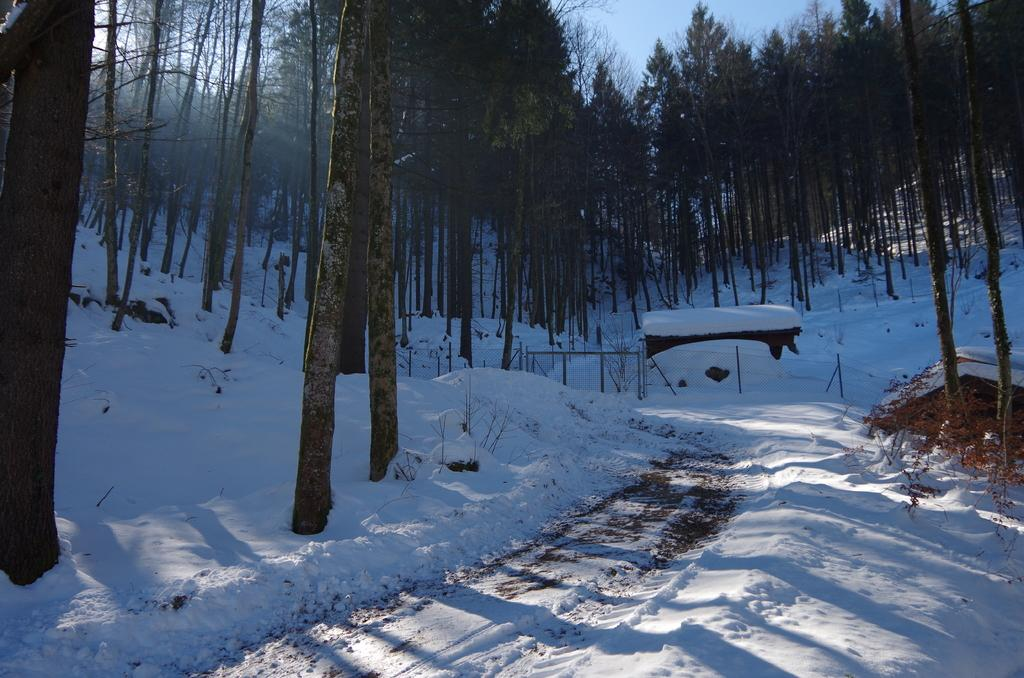What type of surface is shown in the image? The image depicts a snow surface. Are there any objects or structures on the snow surface? No, the only visible elements on the snow surface are tall trees. What type of fuel is being used by the farmer in the image? There is no farmer or fuel present in the image; it only shows a snow surface with tall trees. 